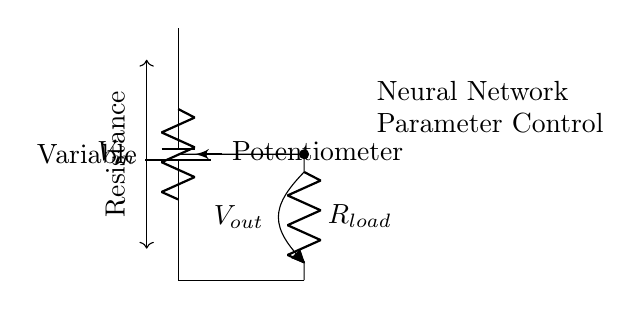what is the input voltage for this circuit? The input voltage, denoted as V_in, is the voltage supplied by the battery connected in the circuit.
Answer: V_in what is the role of the potentiometer in this circuit? The potentiometer serves as a variable resistor, allowing the user to adjust the resistance, and thereby control the output voltage V_out by changing the division of input voltage.
Answer: Variable resistor what is the load resistance symbol in the diagram? The load resistance is represented by "R" in the circuit diagram, indicating that it is connected to the output branch and influences the current through the circuit.
Answer: R how do you determine V_out in this circuit? V_out can be determined using the voltage divider rule, which states that V_out is equal to V_in multiplied by the ratio of the load resistance R_load to the sum of R_load and the resistance of the potentiometer.
Answer: V_out = (V_in * R_load) / (R_load + R_pot) what happens to V_out if the potentiometer is set to maximum resistance? If the potentiometer is set to maximum resistance, it will cause V_out to approach the value of V_in, since a higher resistance in the division decreases current flow through R_load, effectively maximizing V_out.
Answer: Approaches V_in what is indicated by the arrow showing variable resistance in the circuit diagram? The arrow indicates that the potentiometer can vary its resistance, affecting the voltage distribution across the circuit components, which is essential for adjusting parameters in neural network simulations.
Answer: Variable resistance what is the function of the neural network label in this circuit? The neural network label indicates that the output voltage V_out is used to control parameters within a neural network simulation, making it crucial for adjusting the model's behavior or performance.
Answer: Control parameters 